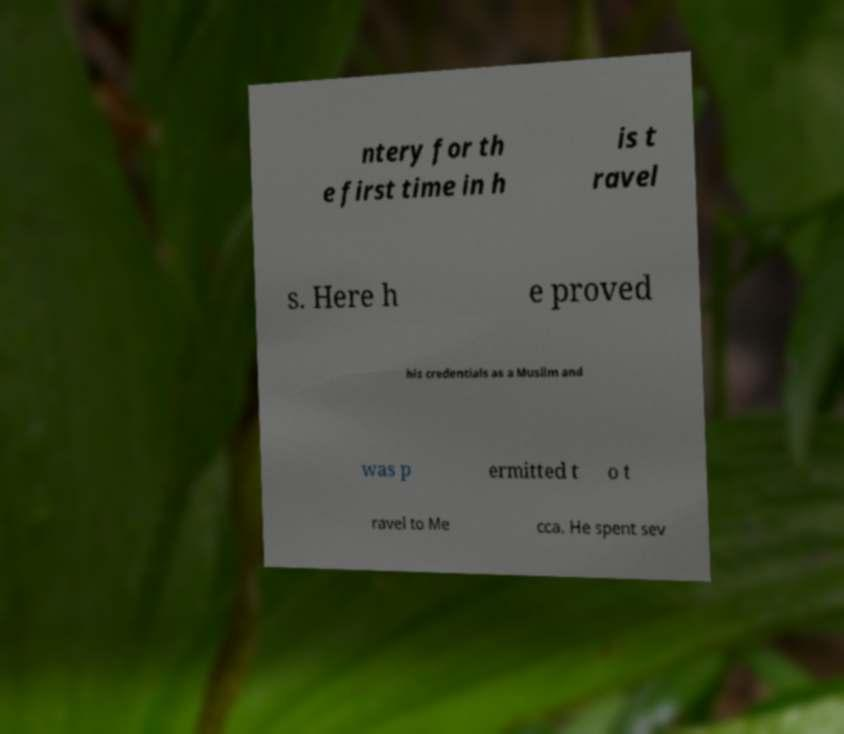Can you read and provide the text displayed in the image?This photo seems to have some interesting text. Can you extract and type it out for me? ntery for th e first time in h is t ravel s. Here h e proved his credentials as a Muslim and was p ermitted t o t ravel to Me cca. He spent sev 